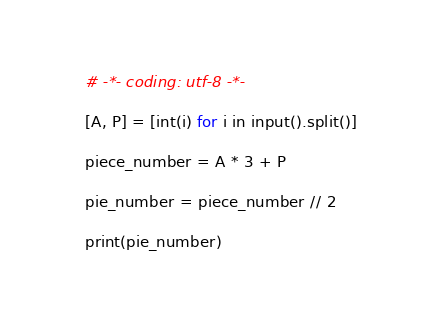Convert code to text. <code><loc_0><loc_0><loc_500><loc_500><_Python_># -*- coding: utf-8 -*-

[A, P] = [int(i) for i in input().split()]

piece_number = A * 3 + P

pie_number = piece_number // 2

print(pie_number)
</code> 